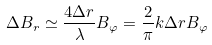<formula> <loc_0><loc_0><loc_500><loc_500>\Delta B _ { r } \simeq \frac { 4 \Delta r } { \lambda } B _ { \varphi } = \frac { 2 } { \pi } k \Delta r B _ { \varphi }</formula> 